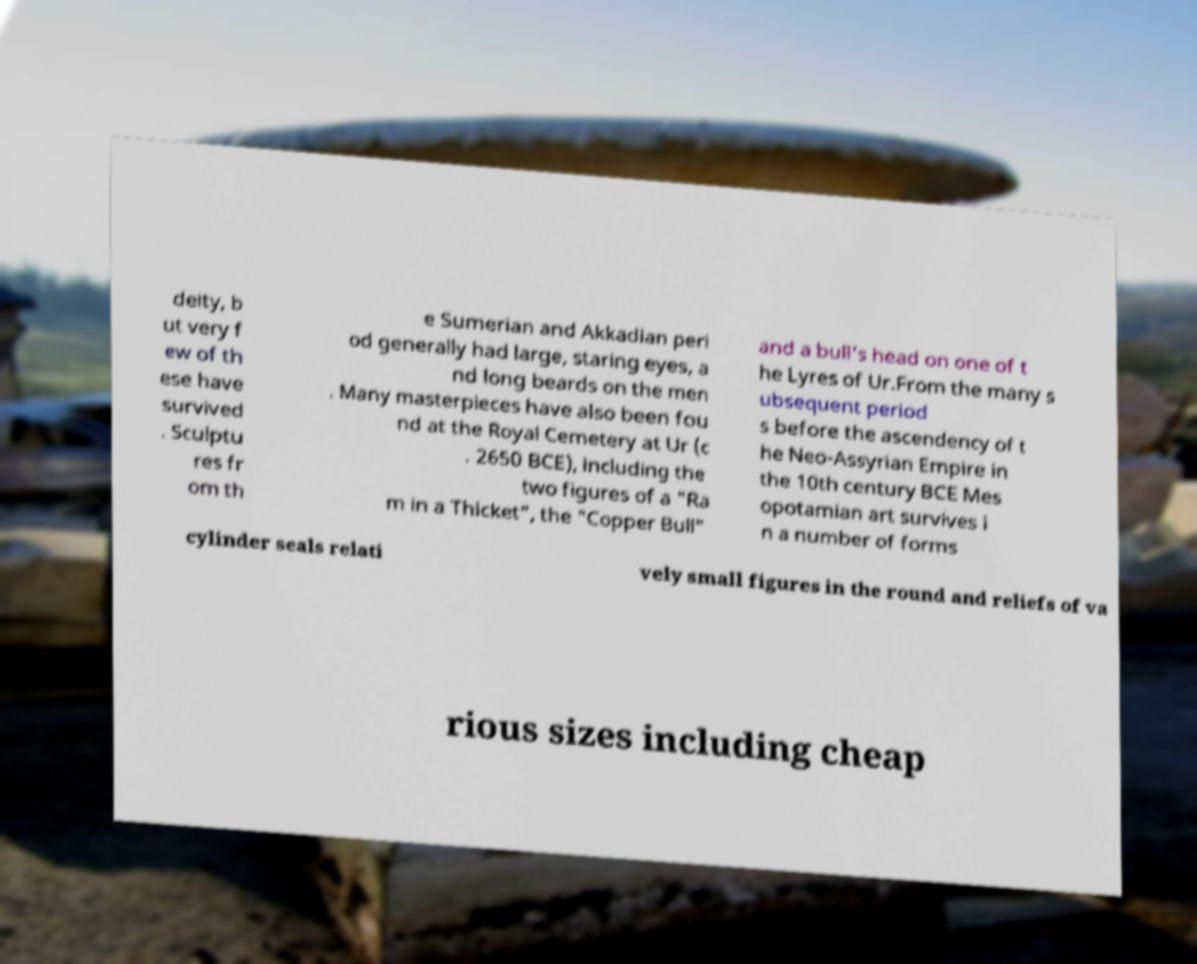Please read and relay the text visible in this image. What does it say? deity, b ut very f ew of th ese have survived . Sculptu res fr om th e Sumerian and Akkadian peri od generally had large, staring eyes, a nd long beards on the men . Many masterpieces have also been fou nd at the Royal Cemetery at Ur (c . 2650 BCE), including the two figures of a "Ra m in a Thicket", the "Copper Bull" and a bull's head on one of t he Lyres of Ur.From the many s ubsequent period s before the ascendency of t he Neo-Assyrian Empire in the 10th century BCE Mes opotamian art survives i n a number of forms cylinder seals relati vely small figures in the round and reliefs of va rious sizes including cheap 